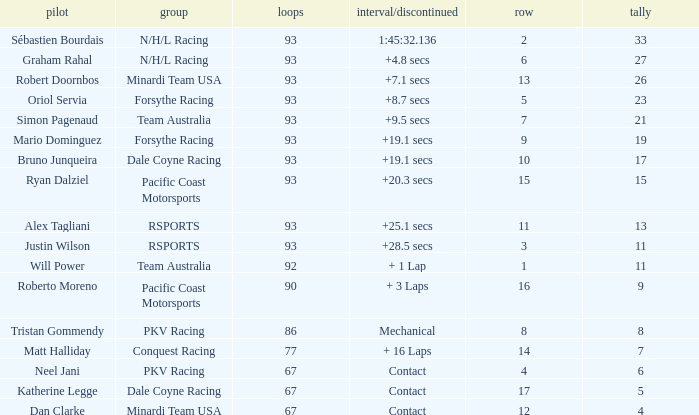What is the grid for the Minardi Team USA with laps smaller than 90? 12.0. I'm looking to parse the entire table for insights. Could you assist me with that? {'header': ['pilot', 'group', 'loops', 'interval/discontinued', 'row', 'tally'], 'rows': [['Sébastien Bourdais', 'N/H/L Racing', '93', '1:45:32.136', '2', '33'], ['Graham Rahal', 'N/H/L Racing', '93', '+4.8 secs', '6', '27'], ['Robert Doornbos', 'Minardi Team USA', '93', '+7.1 secs', '13', '26'], ['Oriol Servia', 'Forsythe Racing', '93', '+8.7 secs', '5', '23'], ['Simon Pagenaud', 'Team Australia', '93', '+9.5 secs', '7', '21'], ['Mario Dominguez', 'Forsythe Racing', '93', '+19.1 secs', '9', '19'], ['Bruno Junqueira', 'Dale Coyne Racing', '93', '+19.1 secs', '10', '17'], ['Ryan Dalziel', 'Pacific Coast Motorsports', '93', '+20.3 secs', '15', '15'], ['Alex Tagliani', 'RSPORTS', '93', '+25.1 secs', '11', '13'], ['Justin Wilson', 'RSPORTS', '93', '+28.5 secs', '3', '11'], ['Will Power', 'Team Australia', '92', '+ 1 Lap', '1', '11'], ['Roberto Moreno', 'Pacific Coast Motorsports', '90', '+ 3 Laps', '16', '9'], ['Tristan Gommendy', 'PKV Racing', '86', 'Mechanical', '8', '8'], ['Matt Halliday', 'Conquest Racing', '77', '+ 16 Laps', '14', '7'], ['Neel Jani', 'PKV Racing', '67', 'Contact', '4', '6'], ['Katherine Legge', 'Dale Coyne Racing', '67', 'Contact', '17', '5'], ['Dan Clarke', 'Minardi Team USA', '67', 'Contact', '12', '4']]} 